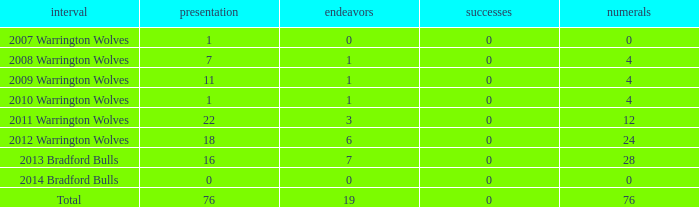What is the sum of appearance when goals is more than 0? None. 